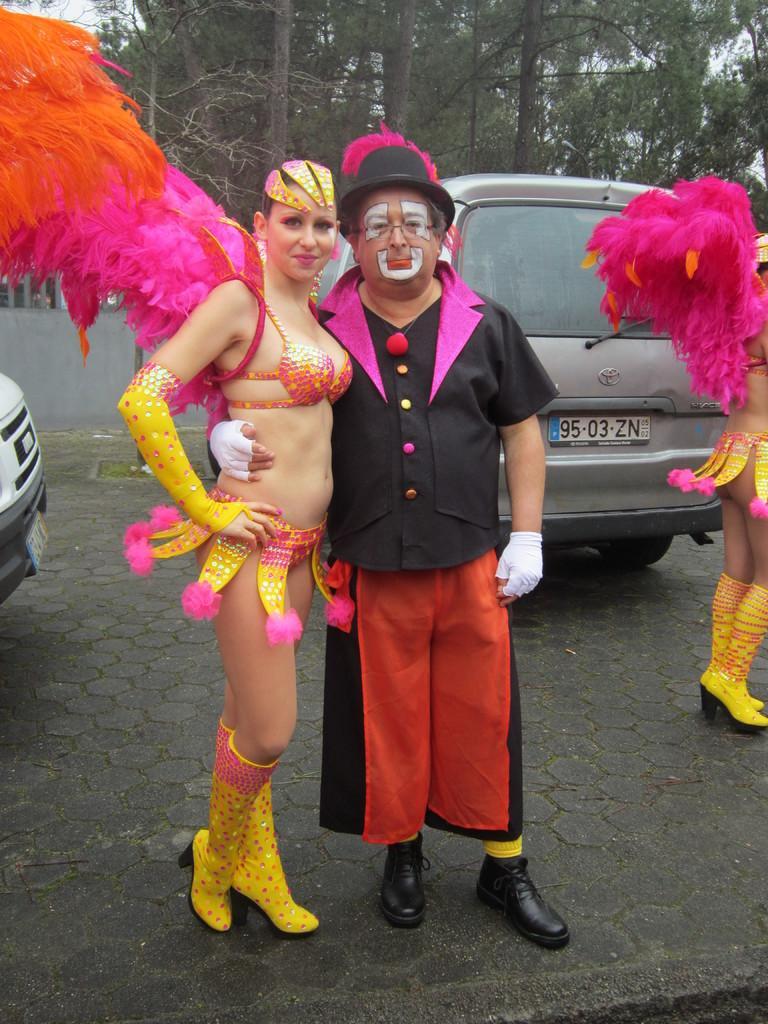Please provide a concise description of this image. In the image in the center we can see two persons were standing and they were smiling,which we can see on their faces. And they were in different costumes. In the background we can see trees,vehicles and one person standing. 